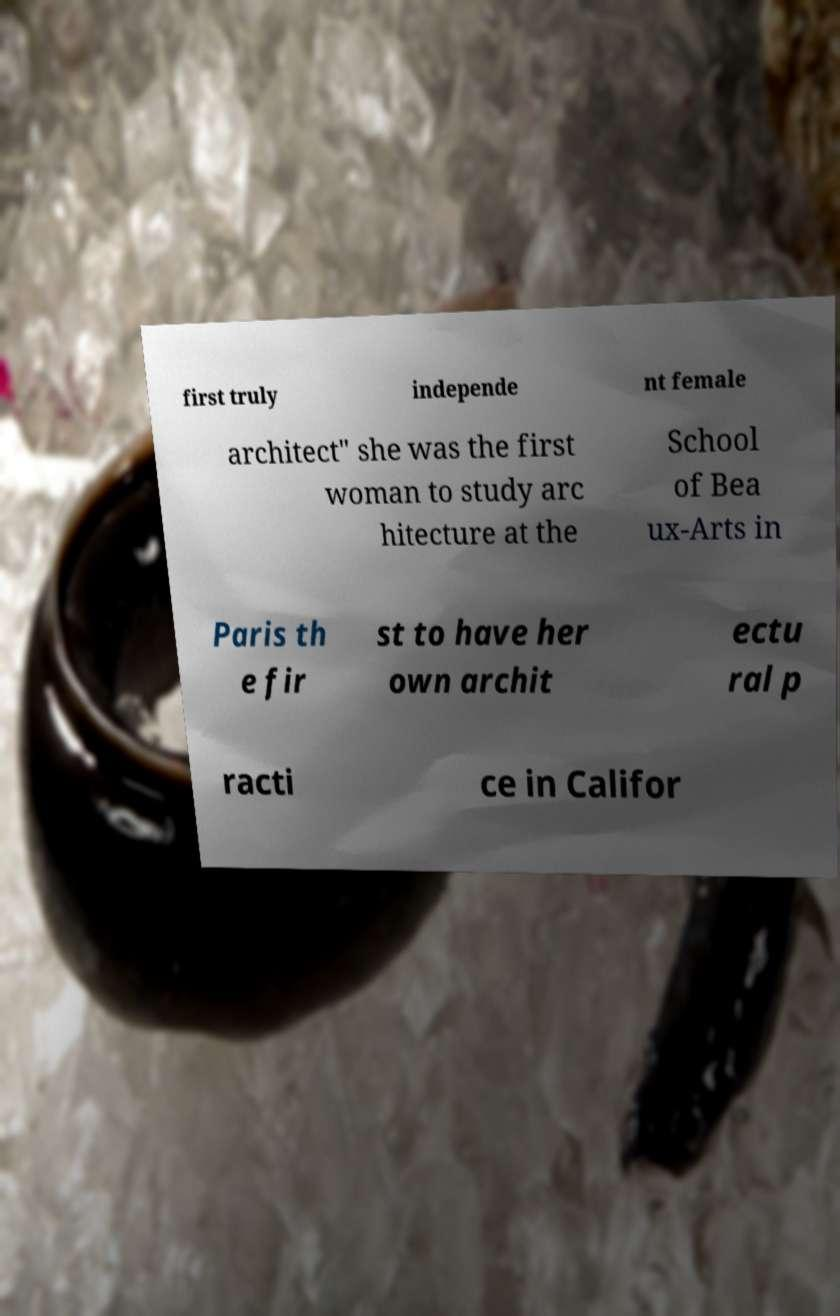For documentation purposes, I need the text within this image transcribed. Could you provide that? first truly independe nt female architect" she was the first woman to study arc hitecture at the School of Bea ux-Arts in Paris th e fir st to have her own archit ectu ral p racti ce in Califor 